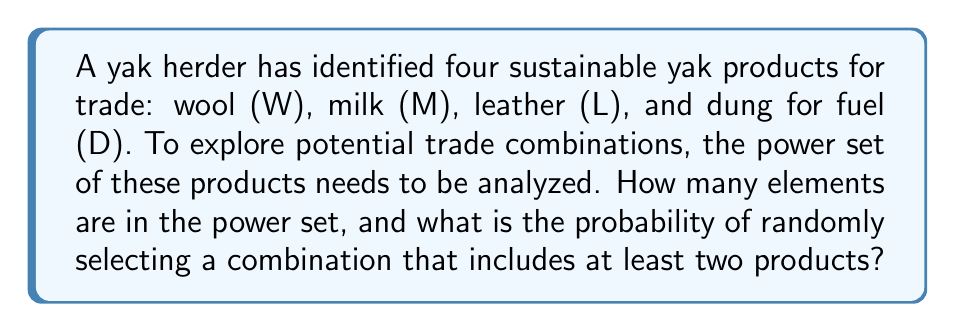What is the answer to this math problem? Let's approach this step-by-step:

1) First, let's recall that the power set of a set S is the set of all subsets of S, including the empty set and S itself.

2) Given the set of yak products $S = \{W, M, L, D\}$, we need to find $P(S)$.

3) The number of elements in a power set is given by the formula:
   $n(P(S)) = 2^n$, where n is the number of elements in the original set.

4) In this case, $n = 4$, so:
   $n(P(S)) = 2^4 = 16$

5) Now, for the probability of selecting a combination with at least two products:
   - Total number of combinations: 16
   - Combinations we don't want: 
     * Empty set: 1
     * Single product combinations: 4
   - Favorable combinations = Total - Unfavorable = $16 - (1 + 4) = 11$

6) Probability = Favorable outcomes / Total outcomes
   $P(\text{at least two products}) = \frac{11}{16}$

Therefore, there are 16 elements in the power set, and the probability of randomly selecting a combination with at least two products is $\frac{11}{16}$.
Answer: The power set contains 16 elements. The probability of randomly selecting a combination that includes at least two products is $\frac{11}{16}$. 